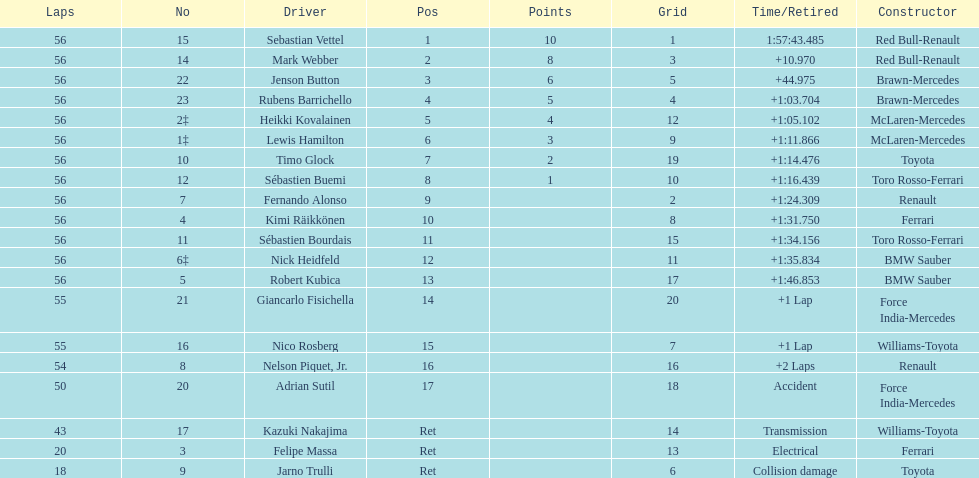How many laps in total is the race? 56. 